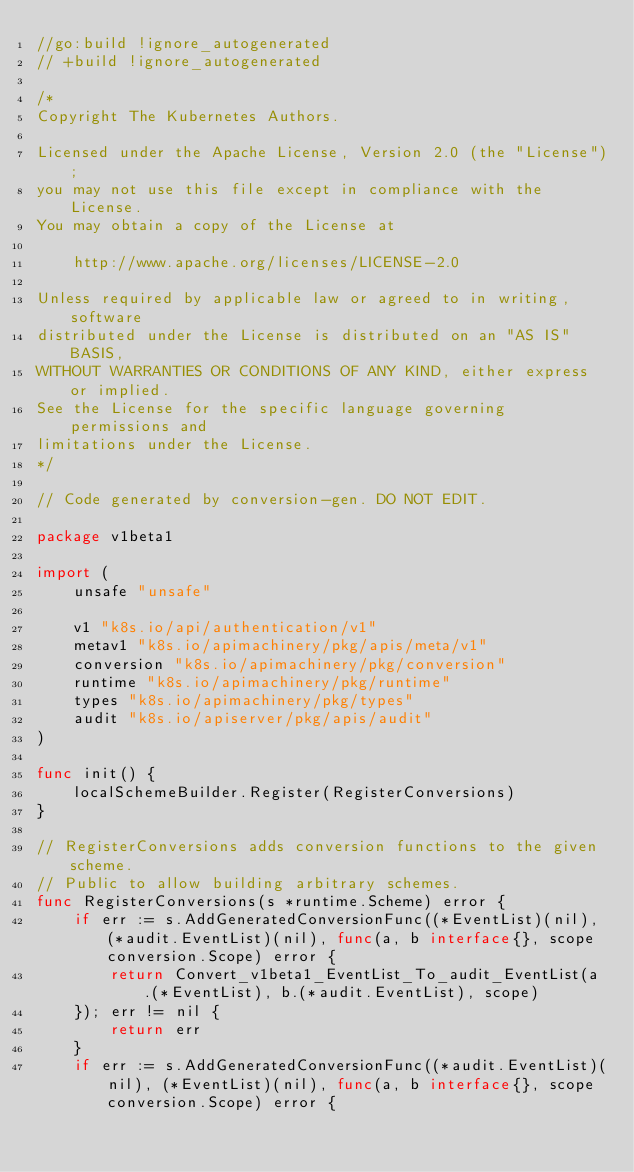<code> <loc_0><loc_0><loc_500><loc_500><_Go_>//go:build !ignore_autogenerated
// +build !ignore_autogenerated

/*
Copyright The Kubernetes Authors.

Licensed under the Apache License, Version 2.0 (the "License");
you may not use this file except in compliance with the License.
You may obtain a copy of the License at

    http://www.apache.org/licenses/LICENSE-2.0

Unless required by applicable law or agreed to in writing, software
distributed under the License is distributed on an "AS IS" BASIS,
WITHOUT WARRANTIES OR CONDITIONS OF ANY KIND, either express or implied.
See the License for the specific language governing permissions and
limitations under the License.
*/

// Code generated by conversion-gen. DO NOT EDIT.

package v1beta1

import (
	unsafe "unsafe"

	v1 "k8s.io/api/authentication/v1"
	metav1 "k8s.io/apimachinery/pkg/apis/meta/v1"
	conversion "k8s.io/apimachinery/pkg/conversion"
	runtime "k8s.io/apimachinery/pkg/runtime"
	types "k8s.io/apimachinery/pkg/types"
	audit "k8s.io/apiserver/pkg/apis/audit"
)

func init() {
	localSchemeBuilder.Register(RegisterConversions)
}

// RegisterConversions adds conversion functions to the given scheme.
// Public to allow building arbitrary schemes.
func RegisterConversions(s *runtime.Scheme) error {
	if err := s.AddGeneratedConversionFunc((*EventList)(nil), (*audit.EventList)(nil), func(a, b interface{}, scope conversion.Scope) error {
		return Convert_v1beta1_EventList_To_audit_EventList(a.(*EventList), b.(*audit.EventList), scope)
	}); err != nil {
		return err
	}
	if err := s.AddGeneratedConversionFunc((*audit.EventList)(nil), (*EventList)(nil), func(a, b interface{}, scope conversion.Scope) error {</code> 